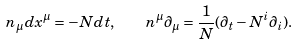<formula> <loc_0><loc_0><loc_500><loc_500>n _ { \mu } d x ^ { \mu } = - N d t , \quad n ^ { \mu } \partial _ { \mu } = \frac { 1 } { N } ( \partial _ { t } - N ^ { i } \partial _ { i } ) .</formula> 